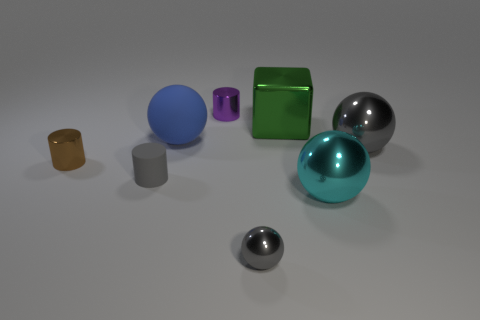Add 1 big blocks. How many objects exist? 9 Subtract all cubes. How many objects are left? 7 Add 7 large cyan cubes. How many large cyan cubes exist? 7 Subtract 0 purple balls. How many objects are left? 8 Subtract all red blocks. Subtract all large spheres. How many objects are left? 5 Add 8 blue objects. How many blue objects are left? 9 